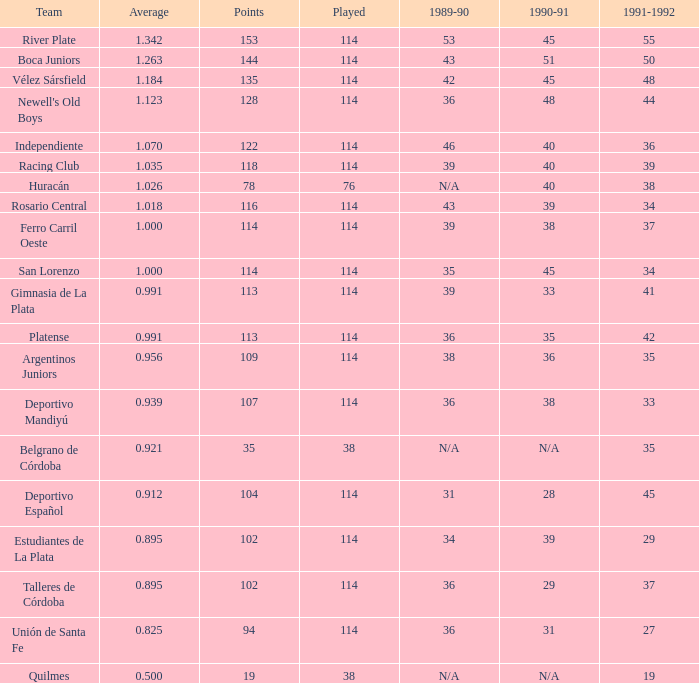What is the mean of a 1989-90 season with 36, a squad of talleres de córdoba, and a participation less than 114? 0.0. 